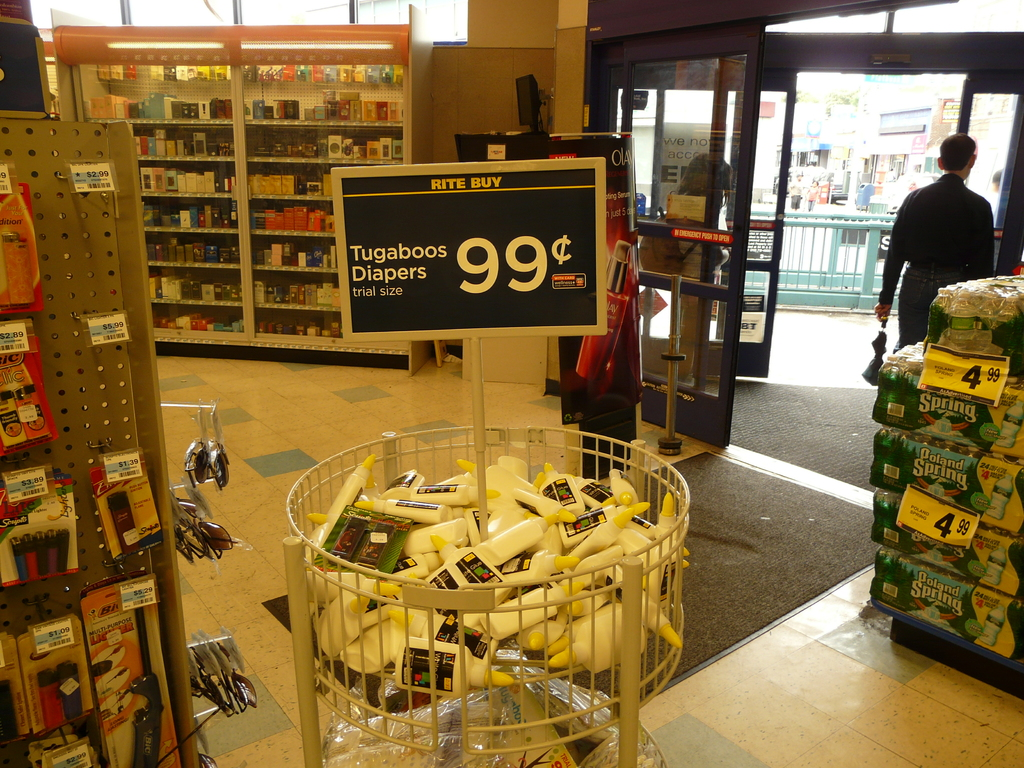Provide a one-sentence caption for the provided image.
Reference OCR token: FEE, RITE, BUY, IT, Diapers, Tugaboos, 99$, -, trialsize, Spring, Spring, Spland, 4.99, Spring Trial sizes of Tugaboos Diapers for sale for only 99 cents. 